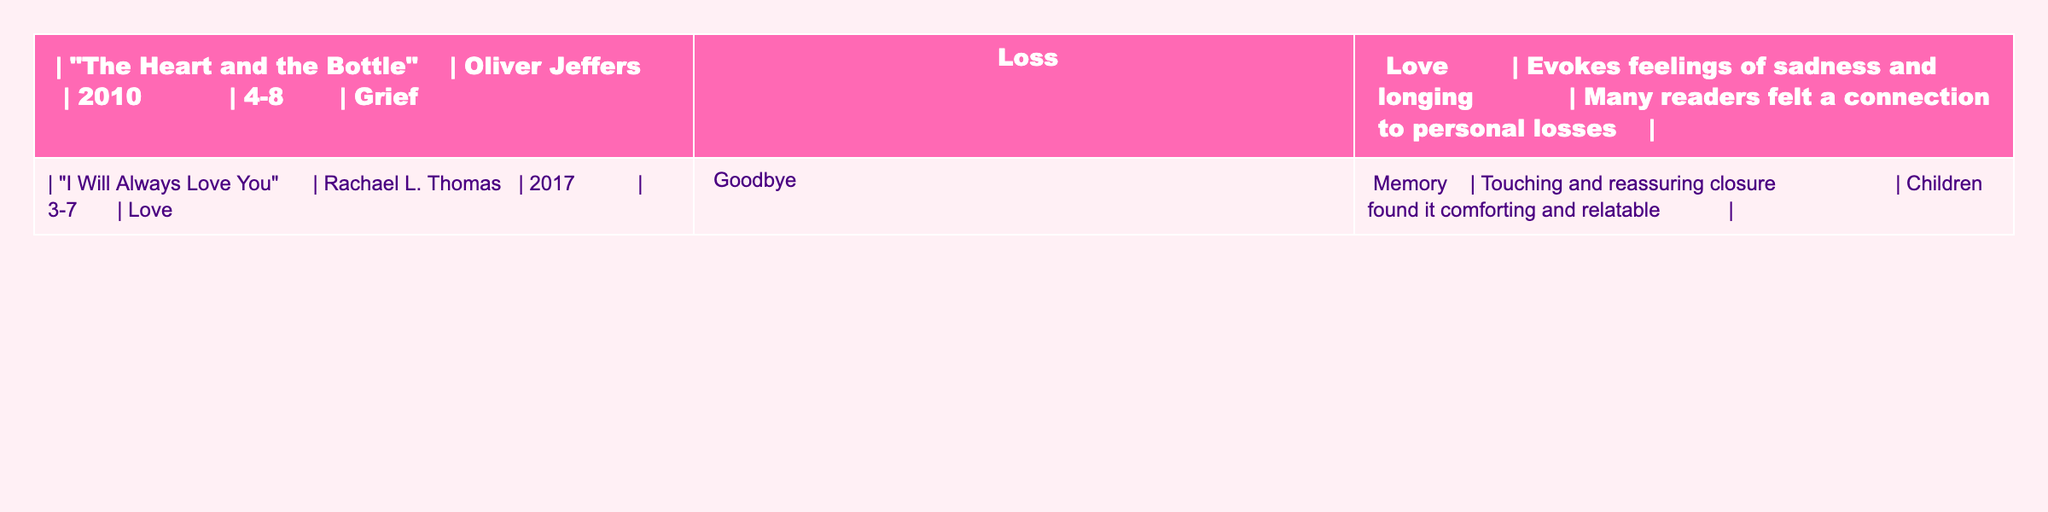What is the title of the book published in 2010? The table lists the publication years of each book alongside their titles. The book with the year 2010 is titled "The Heart and the Bottle".
Answer: "The Heart and the Bottle" How many books are listed in the table? The table showcases two entries, "The Heart and the Bottle" and "I Will Always Love You", indicating that there are two books listed.
Answer: 2 Which author wrote "I Will Always Love You"? By referring to the "I Will Always Love You" row in the table, the author is identified as Rachael L. Thomas.
Answer: Rachael L. Thomas What age range is suggested for "The Heart and the Bottle"? The table reveals that "The Heart and the Bottle" is suggested for children aged 4-8 years.
Answer: 4-8 What themes are common to both books? By reviewing the themes listed for each book, the common themes are both related to love and loss, indicating they share emotional subjects.
Answer: Love, Loss Which book is noted for evoking feelings of sadness and longing? The table states that "The Heart and the Bottle" is specifically recognized for evoking feelings of sadness and longing.
Answer: "The Heart and the Bottle" How is the emotional response to "I Will Always Love You" characterized in the table? The table describes "I Will Always Love You" as having a "touching and reassuring closure," indicating the emotional response is one of comfort.
Answer: Comforting What specific reader connection does "The Heart and the Bottle" evoke? According to the table, many readers felt a connection to personal losses when reading "The Heart and the Bottle," showing its resonance with personal experiences.
Answer: Personal losses Do both books address the theme of grief? The table indicates that "The Heart and the Bottle" includes the theme of grief, and "I Will Always Love You" addresses love and goodbye, which can relate to grief. Thus, both are related to the theme of loss, supporting a "yes" answer.
Answer: Yes Which book involves themes of memory? The table denotes that "I Will Always Love You" includes the theme of memory, specifically within its context of love and goodbye.
Answer: "I Will Always Love You" What is the emotional impact of "I Will Always Love You" on children, according to the table? The table notes that children found "I Will Always Love You" comforting and relatable, indicating its positive emotional impact.
Answer: Comforting and relatable 